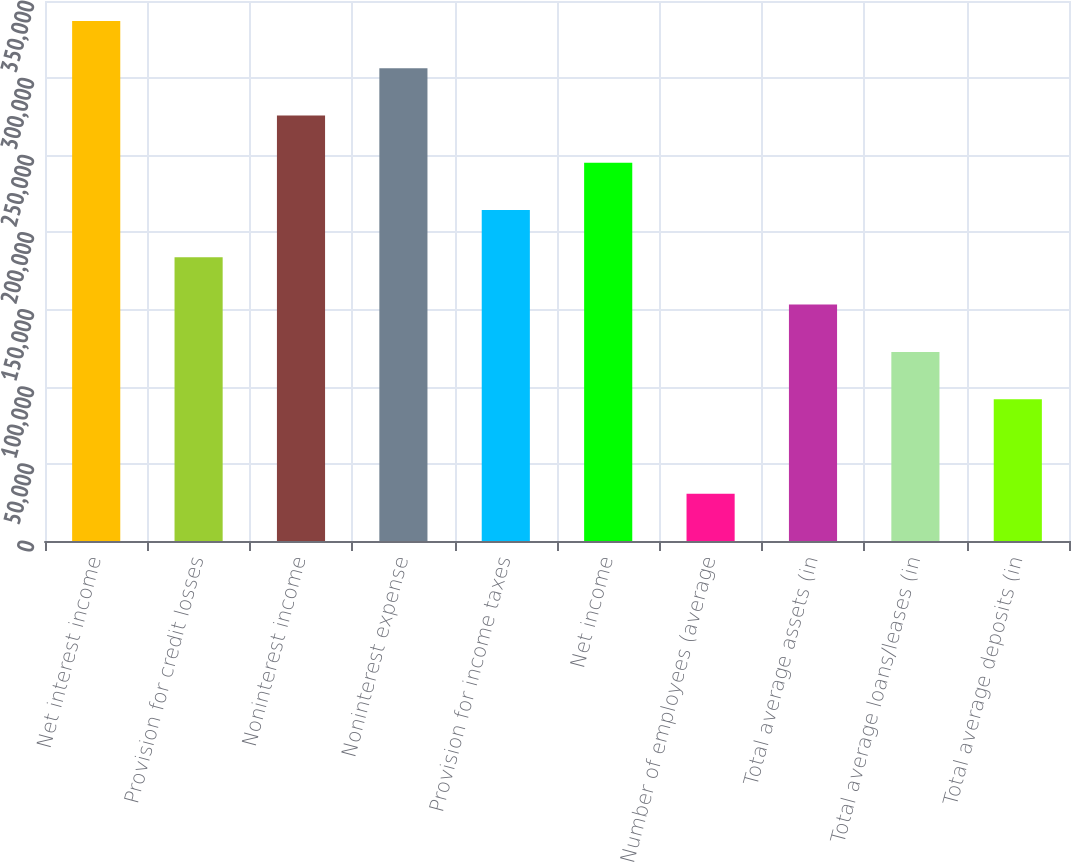Convert chart. <chart><loc_0><loc_0><loc_500><loc_500><bar_chart><fcel>Net interest income<fcel>Provision for credit losses<fcel>Noninterest income<fcel>Noninterest expense<fcel>Provision for income taxes<fcel>Net income<fcel>Number of employees (average<fcel>Total average assets (in<fcel>Total average loans/leases (in<fcel>Total average deposits (in<nl><fcel>337077<fcel>183861<fcel>275791<fcel>306434<fcel>214505<fcel>245148<fcel>30645.7<fcel>153218<fcel>122575<fcel>91932<nl></chart> 